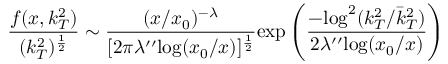Convert formula to latex. <formula><loc_0><loc_0><loc_500><loc_500>\frac { f ( x , k _ { T } ^ { 2 } ) } { ( k _ { T } ^ { 2 } ) ^ { \frac { 1 } { 2 } } } \sim \frac { ( x / x _ { 0 } ) ^ { - \lambda } } { [ 2 \pi \lambda ^ { \prime \prime } \log ( x _ { 0 } / x ) ] ^ { \frac { 1 } { 2 } } } e x p \left ( \frac { - \log ^ { 2 } ( k _ { T } ^ { 2 } / \bar { k } _ { T } ^ { 2 } ) } { 2 \lambda ^ { \prime \prime } \log ( x _ { 0 } / x ) } \right )</formula> 